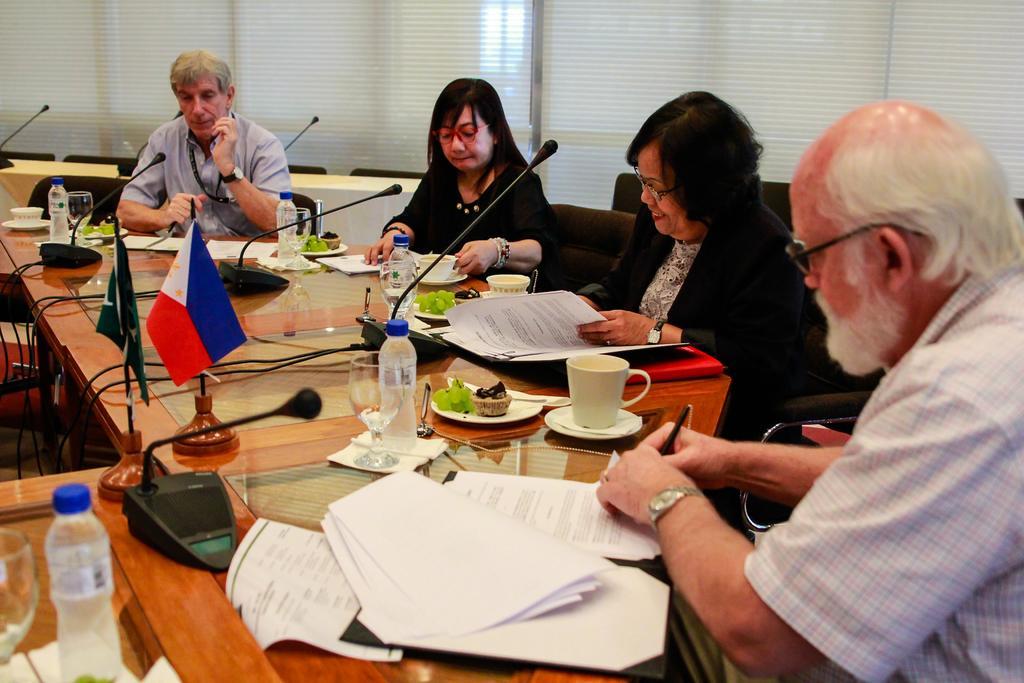Please provide a concise description of this image. In this picture we can see four persons sitting on chairs in front of a table, there are cups, saucers, papers, plates, two flags, microphones, bottles, glasses present on the table, in the background we can see window blinds. 